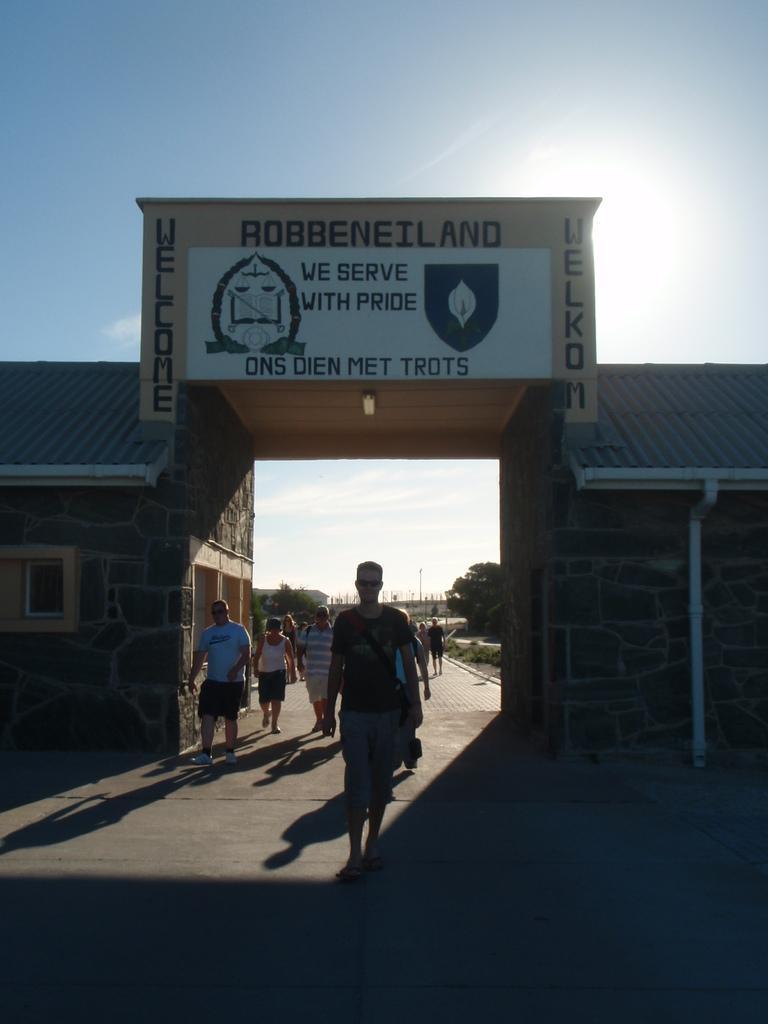Describe this image in one or two sentences. In this image in the center there are some people who are wearing bags and walking, and in the center there is a building and board. On the board there is text, and in the background there are some poles and trees. At the bottom there is walkway and at the top of the image there is sky. 